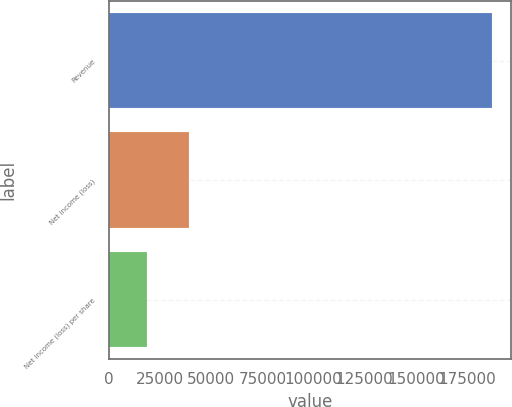<chart> <loc_0><loc_0><loc_500><loc_500><bar_chart><fcel>Revenue<fcel>Net income (loss)<fcel>Net income (loss) per share<nl><fcel>187103<fcel>38957<fcel>18710.6<nl></chart> 